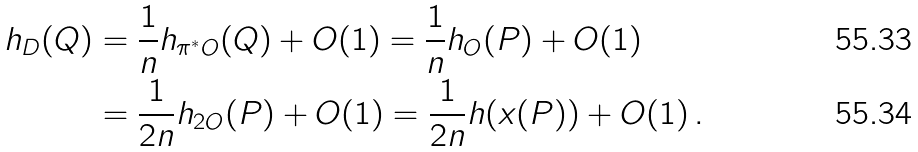Convert formula to latex. <formula><loc_0><loc_0><loc_500><loc_500>h _ { D } ( Q ) & = \frac { 1 } { n } h _ { \pi ^ { * } O } ( Q ) + O ( 1 ) = \frac { 1 } { n } h _ { O } ( P ) + O ( 1 ) \\ & = \frac { 1 } { 2 n } h _ { 2 O } ( P ) + O ( 1 ) = \frac { 1 } { 2 n } h ( x ( P ) ) + O ( 1 ) \, .</formula> 